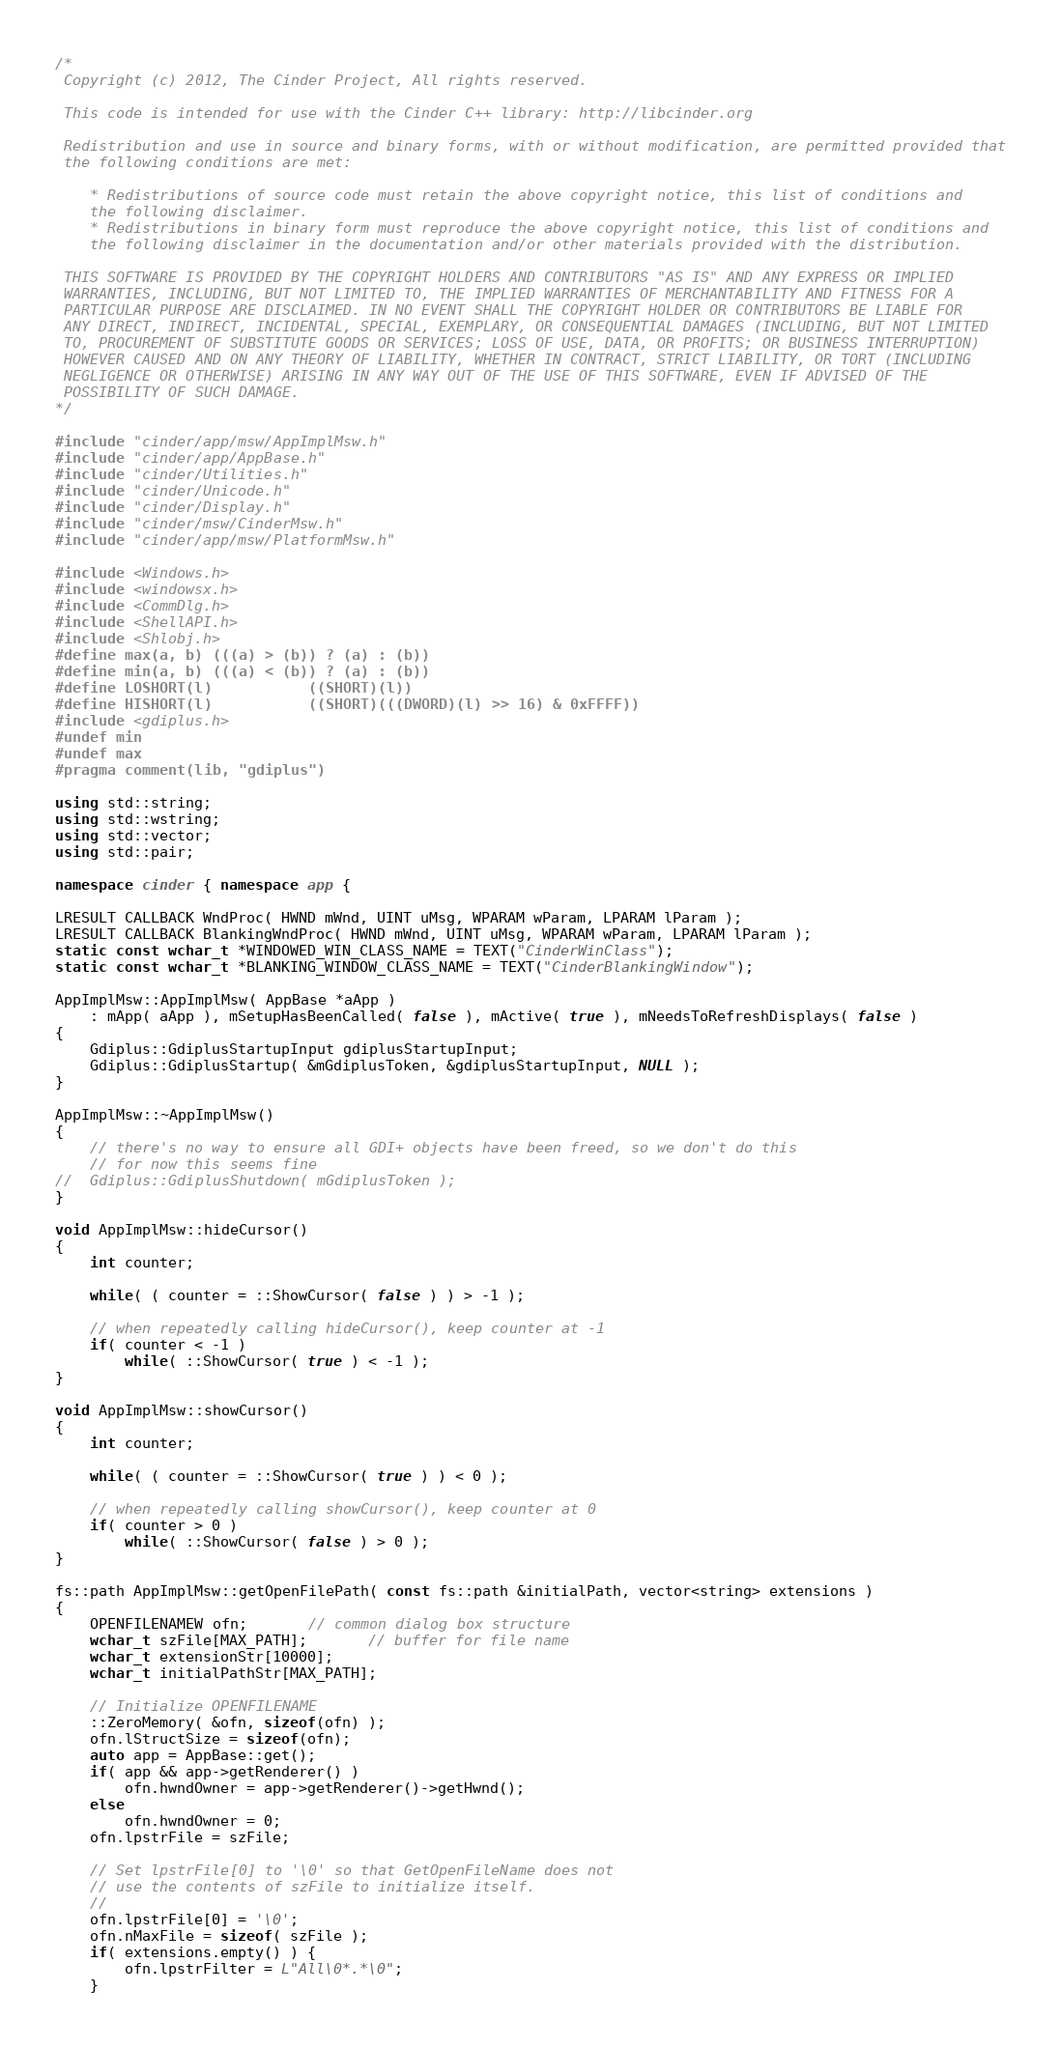<code> <loc_0><loc_0><loc_500><loc_500><_C++_>/*
 Copyright (c) 2012, The Cinder Project, All rights reserved.

 This code is intended for use with the Cinder C++ library: http://libcinder.org

 Redistribution and use in source and binary forms, with or without modification, are permitted provided that
 the following conditions are met:

    * Redistributions of source code must retain the above copyright notice, this list of conditions and
	the following disclaimer.
    * Redistributions in binary form must reproduce the above copyright notice, this list of conditions and
	the following disclaimer in the documentation and/or other materials provided with the distribution.

 THIS SOFTWARE IS PROVIDED BY THE COPYRIGHT HOLDERS AND CONTRIBUTORS "AS IS" AND ANY EXPRESS OR IMPLIED
 WARRANTIES, INCLUDING, BUT NOT LIMITED TO, THE IMPLIED WARRANTIES OF MERCHANTABILITY AND FITNESS FOR A
 PARTICULAR PURPOSE ARE DISCLAIMED. IN NO EVENT SHALL THE COPYRIGHT HOLDER OR CONTRIBUTORS BE LIABLE FOR
 ANY DIRECT, INDIRECT, INCIDENTAL, SPECIAL, EXEMPLARY, OR CONSEQUENTIAL DAMAGES (INCLUDING, BUT NOT LIMITED
 TO, PROCUREMENT OF SUBSTITUTE GOODS OR SERVICES; LOSS OF USE, DATA, OR PROFITS; OR BUSINESS INTERRUPTION)
 HOWEVER CAUSED AND ON ANY THEORY OF LIABILITY, WHETHER IN CONTRACT, STRICT LIABILITY, OR TORT (INCLUDING
 NEGLIGENCE OR OTHERWISE) ARISING IN ANY WAY OUT OF THE USE OF THIS SOFTWARE, EVEN IF ADVISED OF THE
 POSSIBILITY OF SUCH DAMAGE.
*/

#include "cinder/app/msw/AppImplMsw.h"
#include "cinder/app/AppBase.h"
#include "cinder/Utilities.h"
#include "cinder/Unicode.h"
#include "cinder/Display.h"
#include "cinder/msw/CinderMsw.h"
#include "cinder/app/msw/PlatformMsw.h"

#include <Windows.h>
#include <windowsx.h>
#include <CommDlg.h>
#include <ShellAPI.h>
#include <Shlobj.h>
#define max(a, b) (((a) > (b)) ? (a) : (b))
#define min(a, b) (((a) < (b)) ? (a) : (b))
#define LOSHORT(l)           ((SHORT)(l))
#define HISHORT(l)           ((SHORT)(((DWORD)(l) >> 16) & 0xFFFF))
#include <gdiplus.h>
#undef min
#undef max
#pragma comment(lib, "gdiplus")

using std::string;
using std::wstring;
using std::vector;
using std::pair;

namespace cinder { namespace app {

LRESULT CALLBACK WndProc( HWND mWnd, UINT uMsg, WPARAM wParam, LPARAM lParam );
LRESULT CALLBACK BlankingWndProc( HWND mWnd, UINT uMsg, WPARAM wParam, LPARAM lParam );
static const wchar_t *WINDOWED_WIN_CLASS_NAME = TEXT("CinderWinClass");
static const wchar_t *BLANKING_WINDOW_CLASS_NAME = TEXT("CinderBlankingWindow");

AppImplMsw::AppImplMsw( AppBase *aApp )
	: mApp( aApp ), mSetupHasBeenCalled( false ), mActive( true ), mNeedsToRefreshDisplays( false )
{
	Gdiplus::GdiplusStartupInput gdiplusStartupInput;
	Gdiplus::GdiplusStartup( &mGdiplusToken, &gdiplusStartupInput, NULL );
}

AppImplMsw::~AppImplMsw()
{
	// there's no way to ensure all GDI+ objects have been freed, so we don't do this
	// for now this seems fine
//	Gdiplus::GdiplusShutdown( mGdiplusToken );
}

void AppImplMsw::hideCursor()
{
	int counter;

	while( ( counter = ::ShowCursor( false ) ) > -1 );

	// when repeatedly calling hideCursor(), keep counter at -1
	if( counter < -1 )
		while( ::ShowCursor( true ) < -1 );
}

void AppImplMsw::showCursor()
{
	int counter;

	while( ( counter = ::ShowCursor( true ) ) < 0 );

	// when repeatedly calling showCursor(), keep counter at 0
	if( counter > 0 )
		while( ::ShowCursor( false ) > 0 );
}

fs::path AppImplMsw::getOpenFilePath( const fs::path &initialPath, vector<string> extensions )
{
	OPENFILENAMEW ofn;       // common dialog box structure
	wchar_t szFile[MAX_PATH];       // buffer for file name
	wchar_t extensionStr[10000];
	wchar_t initialPathStr[MAX_PATH];

	// Initialize OPENFILENAME
	::ZeroMemory( &ofn, sizeof(ofn) );
	ofn.lStructSize = sizeof(ofn);
	auto app = AppBase::get();
	if( app && app->getRenderer() )
		ofn.hwndOwner = app->getRenderer()->getHwnd();
	else
		ofn.hwndOwner = 0;
	ofn.lpstrFile = szFile;
	
	// Set lpstrFile[0] to '\0' so that GetOpenFileName does not
	// use the contents of szFile to initialize itself.
	//
	ofn.lpstrFile[0] = '\0';
	ofn.nMaxFile = sizeof( szFile );
	if( extensions.empty() ) {
		ofn.lpstrFilter = L"All\0*.*\0";
	}</code> 